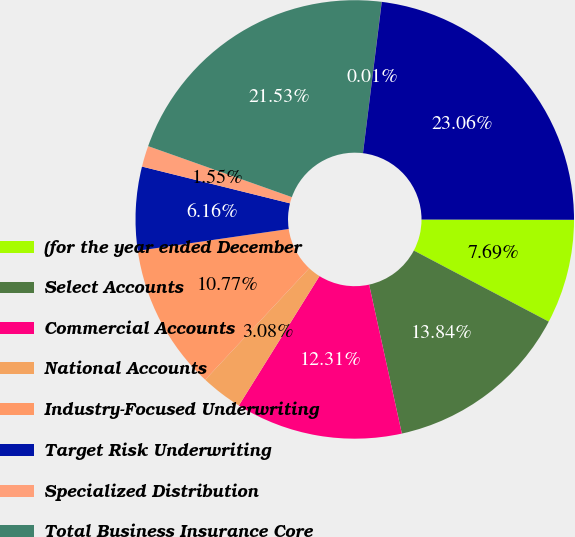Convert chart to OTSL. <chart><loc_0><loc_0><loc_500><loc_500><pie_chart><fcel>(for the year ended December<fcel>Select Accounts<fcel>Commercial Accounts<fcel>National Accounts<fcel>Industry-Focused Underwriting<fcel>Target Risk Underwriting<fcel>Specialized Distribution<fcel>Total Business Insurance Core<fcel>Business Insurance Other<fcel>Total Business Insurance<nl><fcel>7.69%<fcel>13.84%<fcel>12.31%<fcel>3.08%<fcel>10.77%<fcel>6.16%<fcel>1.55%<fcel>21.53%<fcel>0.01%<fcel>23.06%<nl></chart> 